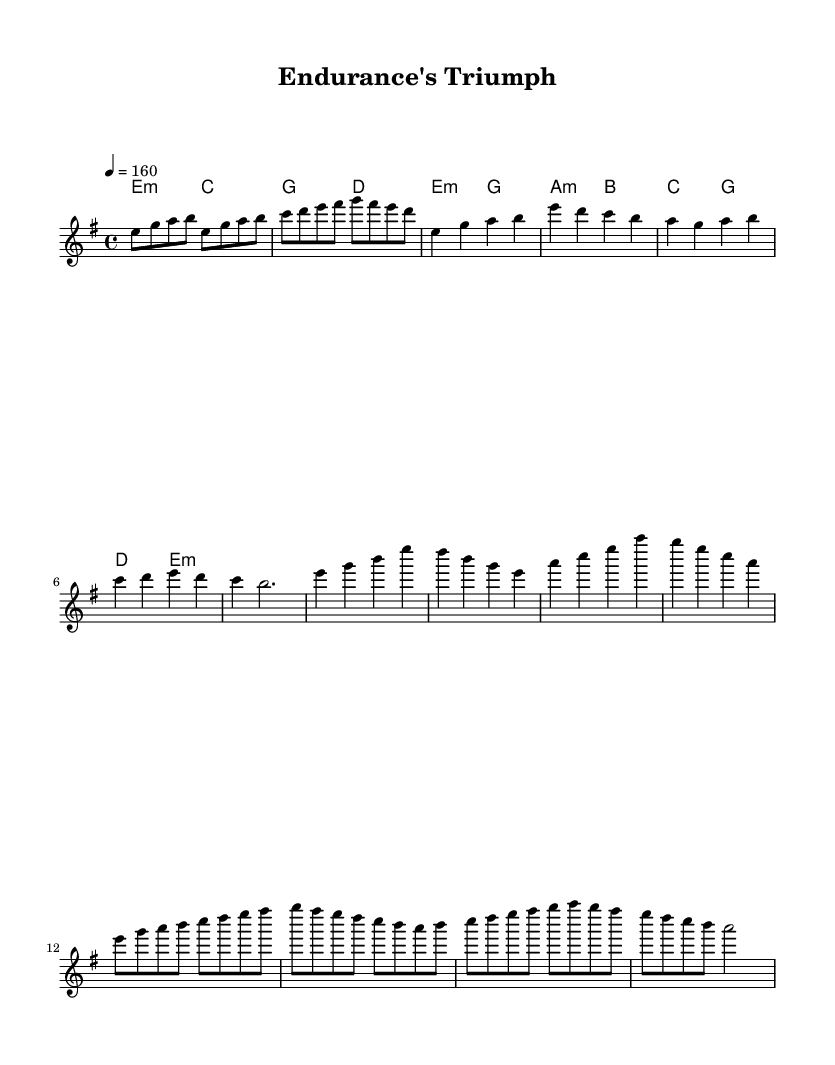What is the key signature of this music? The key signature for this piece is E minor, as indicated by the presence of one sharp (F#) which is common in E minor.
Answer: E minor What is the time signature of the music? The time signature is 4/4, which is evident from the notation at the beginning of the score, indicating four beats in a measure.
Answer: 4/4 What is the tempo marking for the piece? The tempo marking shown at the beginning is 4 equals 160, which indicates the piece should be played at a brisk pace of 160 beats per minute.
Answer: 160 How many measures are in the verse section? The verse section contains four measures, as counted from the melody part of the score which clearly shows four separate groupings of beats.
Answer: 4 What chord is used in the chorus that is not in the verse? The chord A minor appears in the chorus section only, which differentiates it from the verse where different chords are used.
Answer: A minor What is the highest note in the melody section? The highest note in the melody section is B, which can be identified by scanning the melody line for the topmost pitch throughout the measures.
Answer: B What characterizes the music type as melodic power metal? The piece features strong melodies and anthemic choruses, typical characteristics of melodic power metal, which often involves themes of endurance and overcoming obstacles, conveyed through its structure and harmonies.
Answer: Strong melodies 